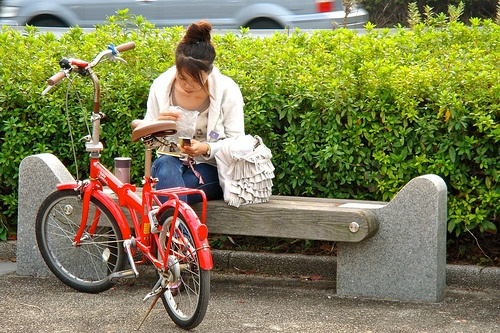Describe the objects in this image and their specific colors. I can see bench in black, gray, and darkgray tones, bicycle in black, gray, red, and darkgray tones, people in black, white, gray, and maroon tones, car in black, darkgray, lightgray, and lightblue tones, and handbag in black, white, darkgray, and lightgray tones in this image. 